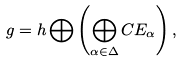<formula> <loc_0><loc_0><loc_500><loc_500>g = { h } \bigoplus \left ( \bigoplus _ { \alpha \in \Delta } { C } E _ { \alpha } \right ) ,</formula> 